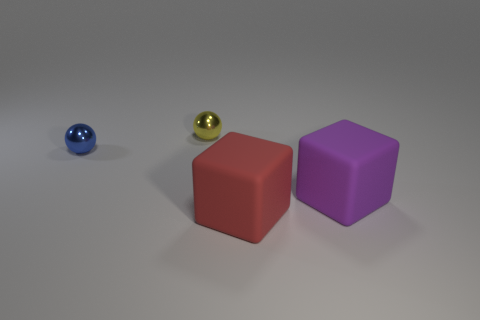How would you describe the arrangement of the objects? The objects are arranged in an orderly fashion on a flat surface with adequate spacing between them, possibly to showcase their shapes and colors. To the left, there's a small blue ball, in the center, a gold sphere, and to the right are two large cubes—one red and one purple. The placement may be deliberate to convey a sense of balance and to allow each object to be clearly observed without interference from the others. 